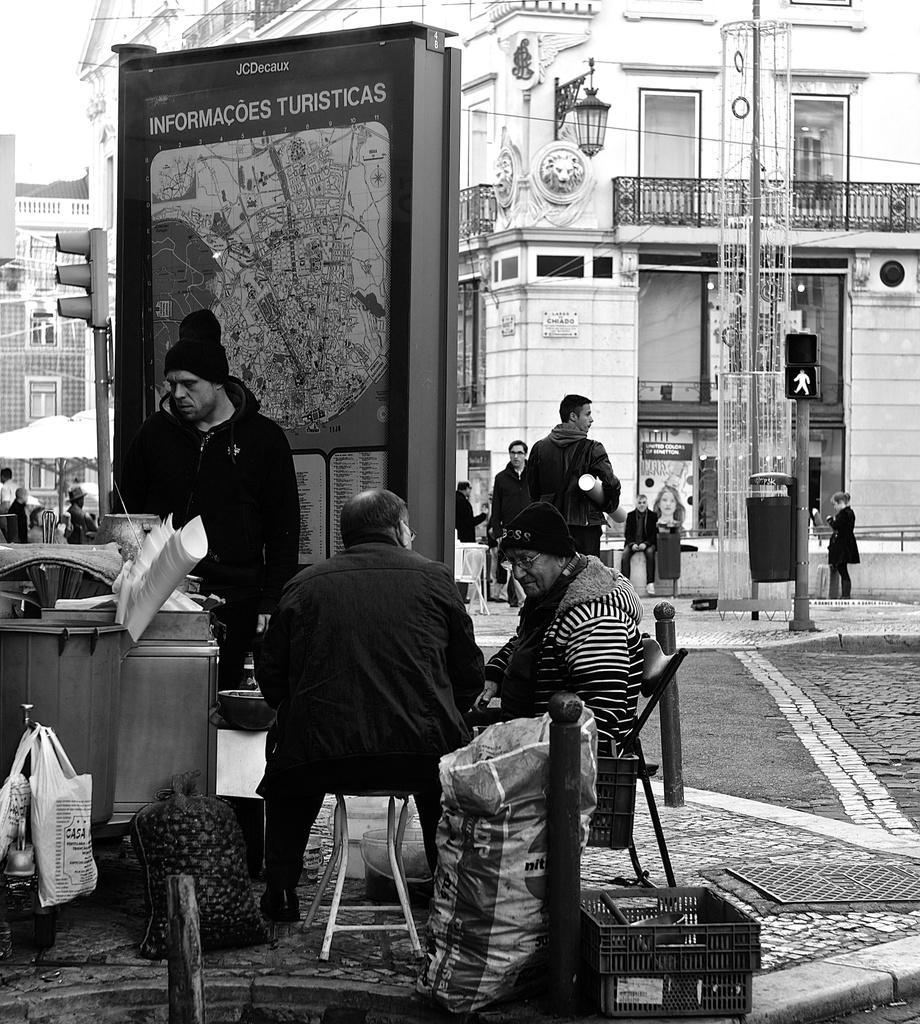Can you describe this image briefly? In this picture there some people sitting on the chair at bottom and right side one girl is standing and some another people are also sitting on the back and one man is standing at the left side. 